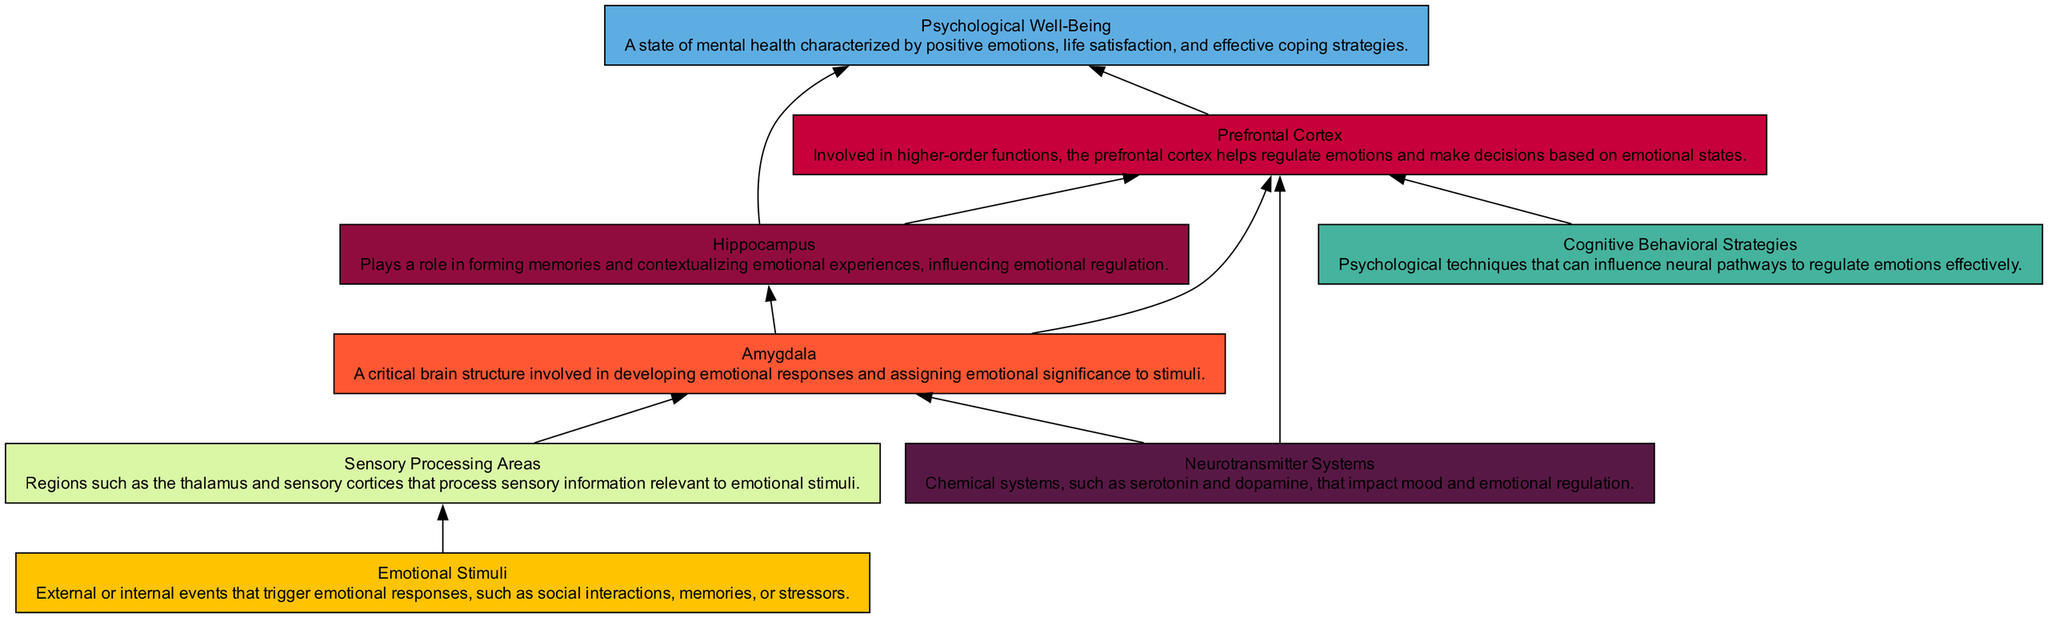What is the first node in the diagram? The first node listed in the diagram is "Emotional Stimuli", which refers to external or internal events that trigger emotional responses.
Answer: Emotional Stimuli How many nodes are present in the diagram? By counting each unique element in the diagram, we find that there are eight nodes, which represent different components related to emotional regulation.
Answer: 8 Which node connects directly to the Prefrontal Cortex? The Prefrontal Cortex connects directly to two nodes: the Amygdala and Cognitive Behavioral Strategies, based on the edges shown in the diagram.
Answer: Amygdala, Cognitive Behavioral Strategies What role does the Hippocampus play in emotional regulation? The Hippocampus is connected to both the Amygdala and the Prefrontal Cortex, indicating that it plays a role in forming memories and contextualizing emotional experiences, influencing emotional regulation.
Answer: Forming memories How do Neurotransmitter Systems influence the Amygdala? The Neurotransmitter Systems connect directly to the Amygdala, suggesting that chemical systems like serotonin and dopamine can impact its function and emotional processing.
Answer: Impact its function Which two nodes lead to Psychological Well-Being? Psychological Well-Being is reached through connections from the Prefrontal Cortex and the Hippocampus, integrating emotional regulation and memory.
Answer: Prefrontal Cortex, Hippocampus What type of strategies can influence the Prefrontal Cortex? Cognitive Behavioral Strategies are depicted as the node that can influence the Prefrontal Cortex in the emotional regulation pathways.
Answer: Cognitive Behavioral Strategies How many edges are shown in the diagram? Upon examining the diagram, we see that there are ten edges connecting various nodes, indicating the relationships between them in the context of emotional regulation.
Answer: 10 What is the relationship between the Amygdala and Neurotransmitter Systems? The Neurotransmitter Systems act upon the Amygdala, illustrating that the chemical influences take effect in the emotional processing carried out by this structure.
Answer: Chemical influences 